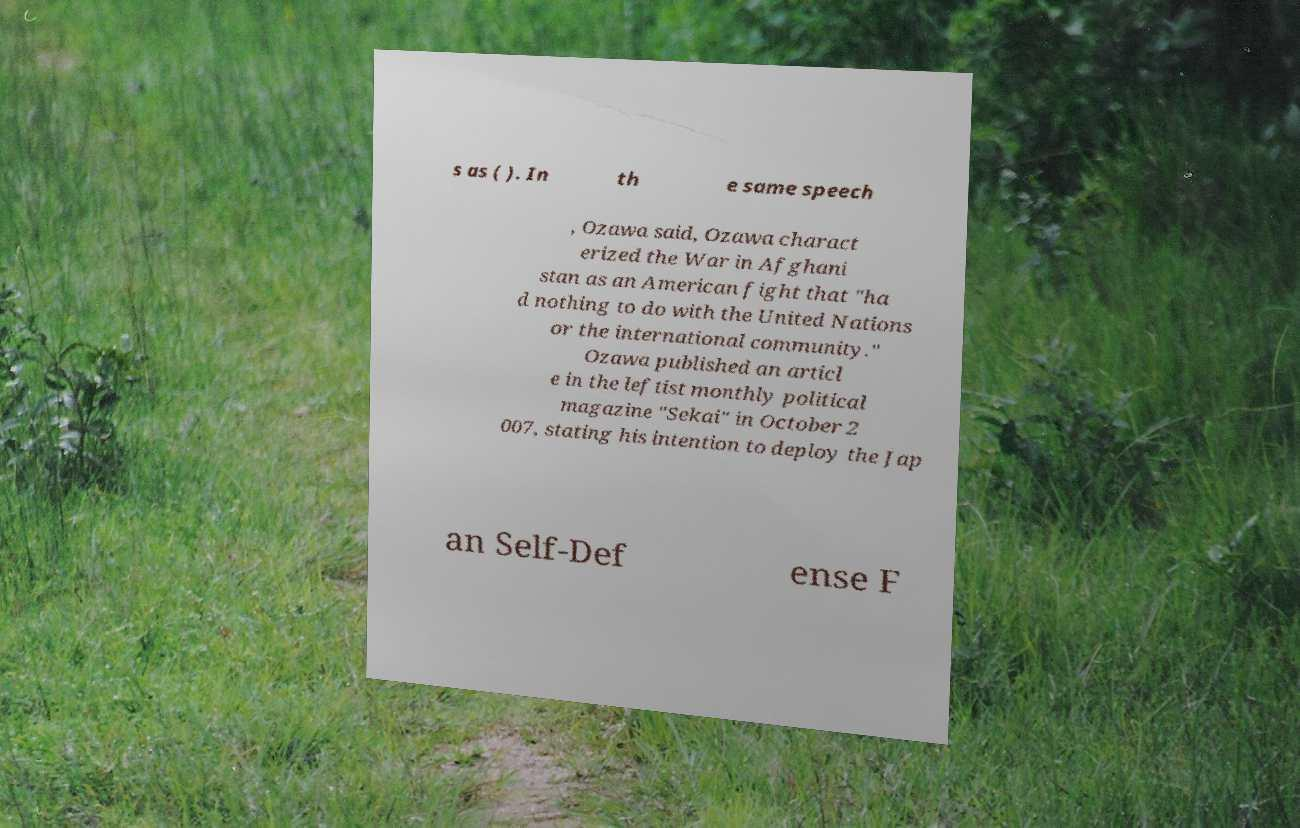I need the written content from this picture converted into text. Can you do that? s as ( ). In th e same speech , Ozawa said, Ozawa charact erized the War in Afghani stan as an American fight that "ha d nothing to do with the United Nations or the international community." Ozawa published an articl e in the leftist monthly political magazine "Sekai" in October 2 007, stating his intention to deploy the Jap an Self-Def ense F 